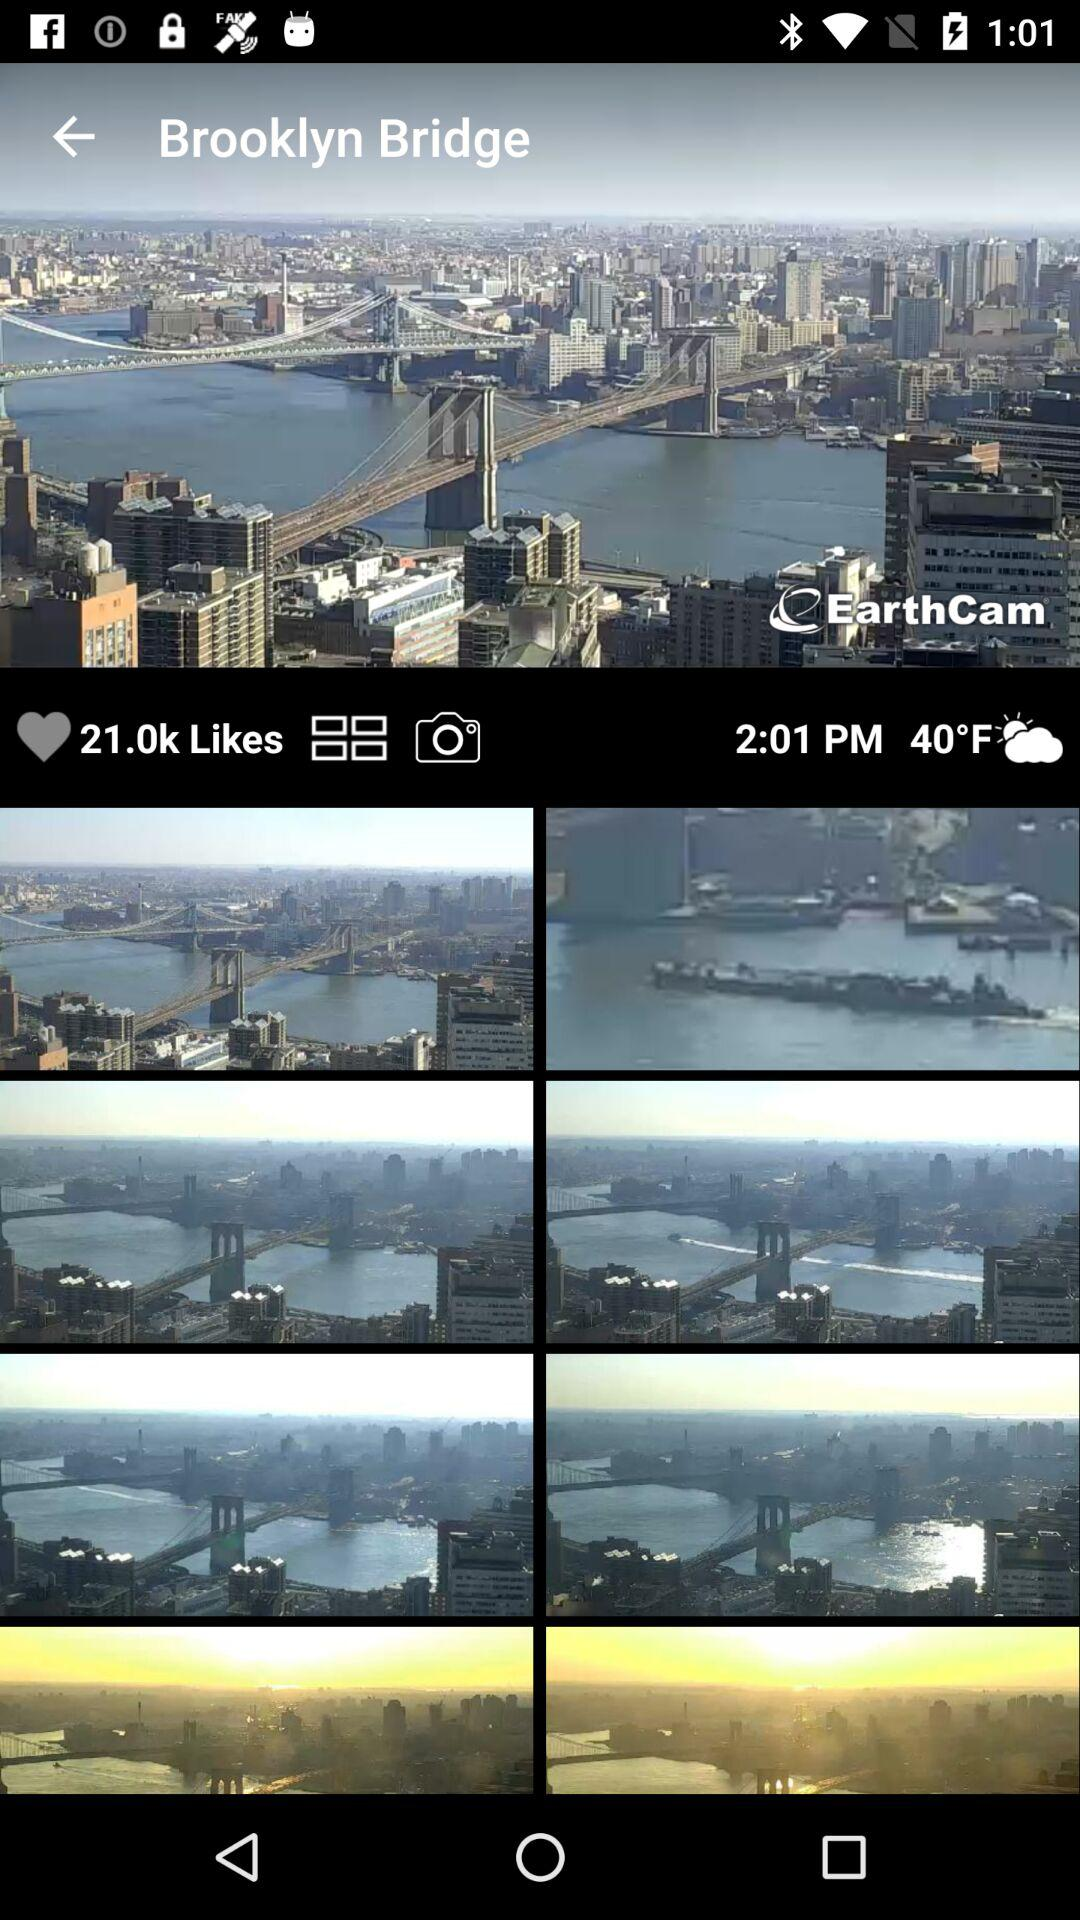What is the temperature? The temperature is 40 °F. 